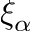Convert formula to latex. <formula><loc_0><loc_0><loc_500><loc_500>\xi _ { \alpha }</formula> 